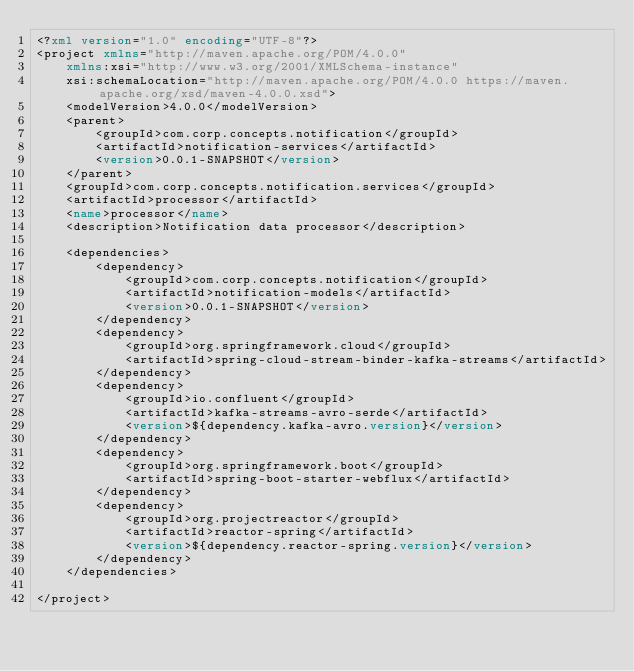<code> <loc_0><loc_0><loc_500><loc_500><_XML_><?xml version="1.0" encoding="UTF-8"?>
<project xmlns="http://maven.apache.org/POM/4.0.0"
	xmlns:xsi="http://www.w3.org/2001/XMLSchema-instance"
	xsi:schemaLocation="http://maven.apache.org/POM/4.0.0 https://maven.apache.org/xsd/maven-4.0.0.xsd">
	<modelVersion>4.0.0</modelVersion>
	<parent>
		<groupId>com.corp.concepts.notification</groupId>
		<artifactId>notification-services</artifactId>
		<version>0.0.1-SNAPSHOT</version>
	</parent>
	<groupId>com.corp.concepts.notification.services</groupId>
	<artifactId>processor</artifactId>
	<name>processor</name>
	<description>Notification data processor</description>

	<dependencies>
		<dependency>
			<groupId>com.corp.concepts.notification</groupId>
			<artifactId>notification-models</artifactId>
			<version>0.0.1-SNAPSHOT</version>
		</dependency>
		<dependency>
			<groupId>org.springframework.cloud</groupId>
			<artifactId>spring-cloud-stream-binder-kafka-streams</artifactId>
		</dependency>
		<dependency>
			<groupId>io.confluent</groupId>
			<artifactId>kafka-streams-avro-serde</artifactId>
			<version>${dependency.kafka-avro.version}</version>
		</dependency>
		<dependency>
			<groupId>org.springframework.boot</groupId>
			<artifactId>spring-boot-starter-webflux</artifactId>
		</dependency>
		<dependency>
			<groupId>org.projectreactor</groupId>
			<artifactId>reactor-spring</artifactId>
			<version>${dependency.reactor-spring.version}</version>
		</dependency>
	</dependencies>

</project>
</code> 